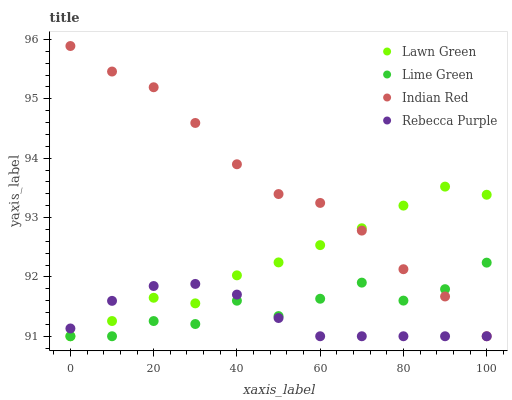Does Rebecca Purple have the minimum area under the curve?
Answer yes or no. Yes. Does Indian Red have the maximum area under the curve?
Answer yes or no. Yes. Does Lime Green have the minimum area under the curve?
Answer yes or no. No. Does Lime Green have the maximum area under the curve?
Answer yes or no. No. Is Rebecca Purple the smoothest?
Answer yes or no. Yes. Is Lime Green the roughest?
Answer yes or no. Yes. Is Lime Green the smoothest?
Answer yes or no. No. Is Rebecca Purple the roughest?
Answer yes or no. No. Does Lawn Green have the lowest value?
Answer yes or no. Yes. Does Indian Red have the highest value?
Answer yes or no. Yes. Does Lime Green have the highest value?
Answer yes or no. No. Does Rebecca Purple intersect Indian Red?
Answer yes or no. Yes. Is Rebecca Purple less than Indian Red?
Answer yes or no. No. Is Rebecca Purple greater than Indian Red?
Answer yes or no. No. 